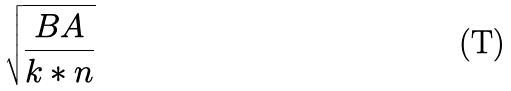Convert formula to latex. <formula><loc_0><loc_0><loc_500><loc_500>\sqrt { \frac { B A } { k * n } }</formula> 